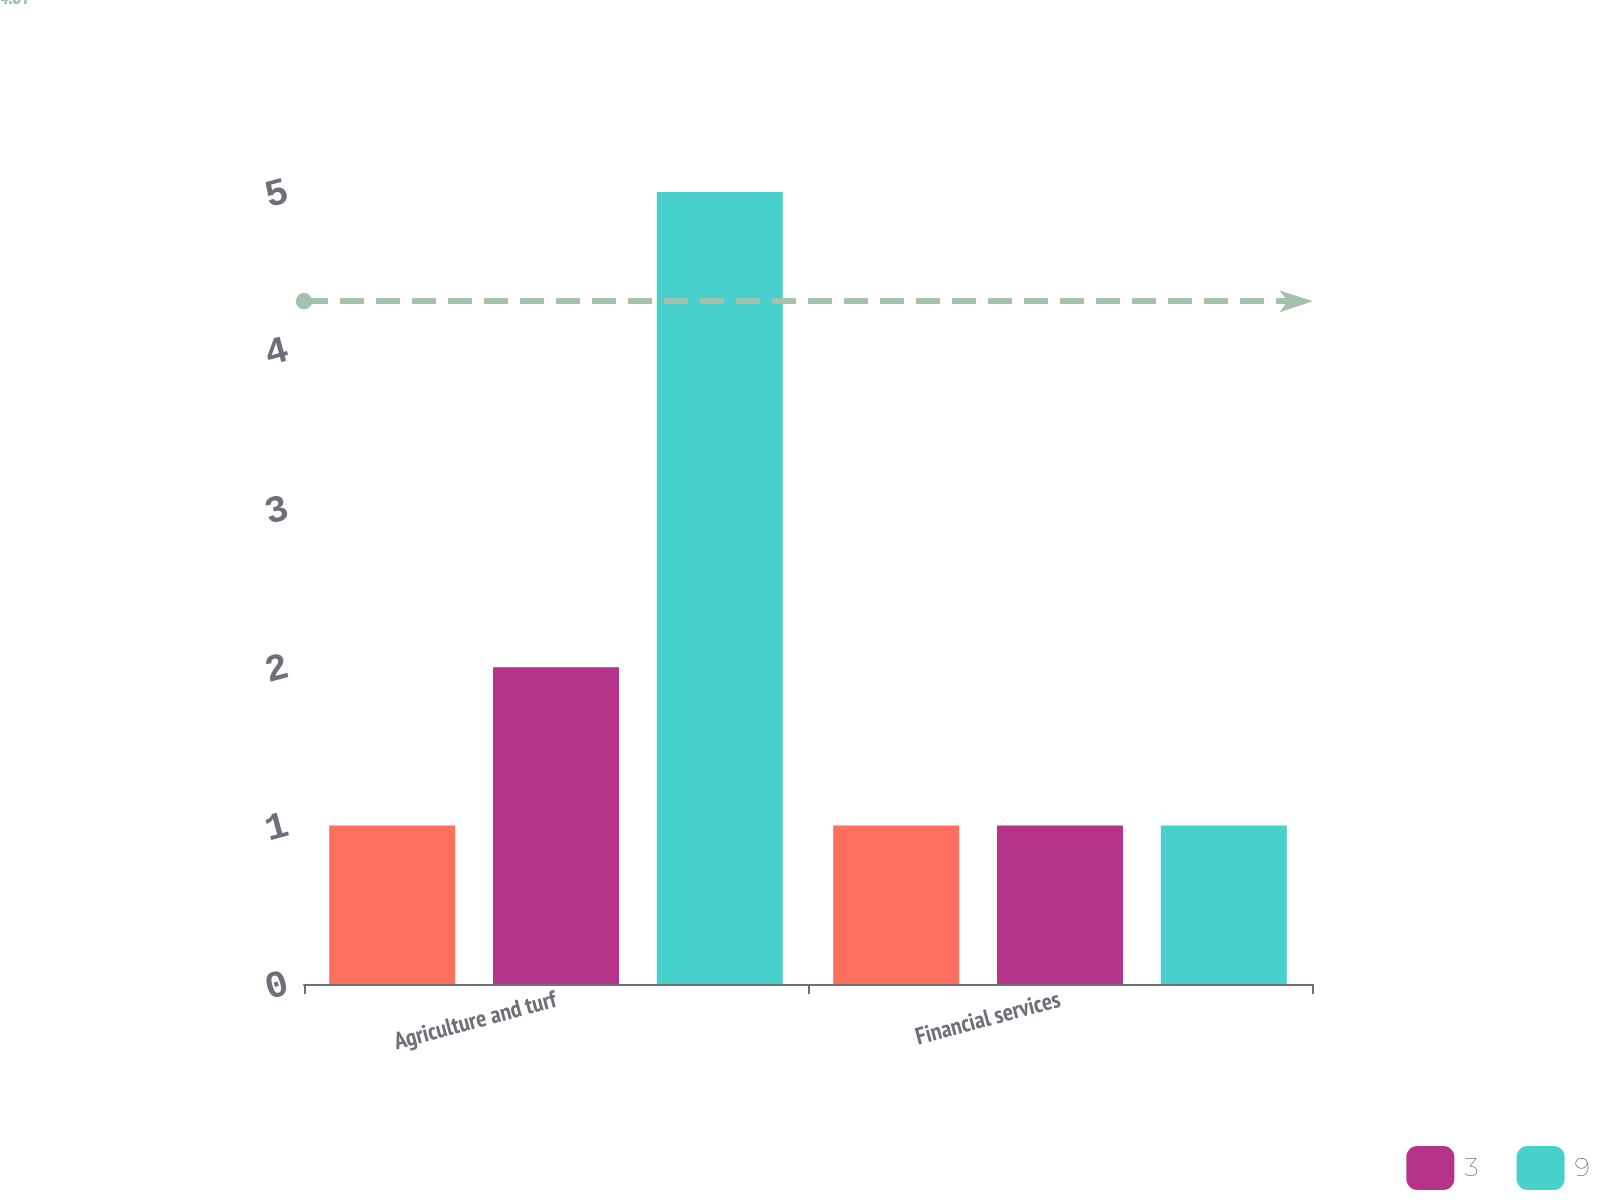<chart> <loc_0><loc_0><loc_500><loc_500><stacked_bar_chart><ecel><fcel>Agriculture and turf<fcel>Financial services<nl><fcel>nan<fcel>1<fcel>1<nl><fcel>3<fcel>2<fcel>1<nl><fcel>9<fcel>5<fcel>1<nl></chart> 